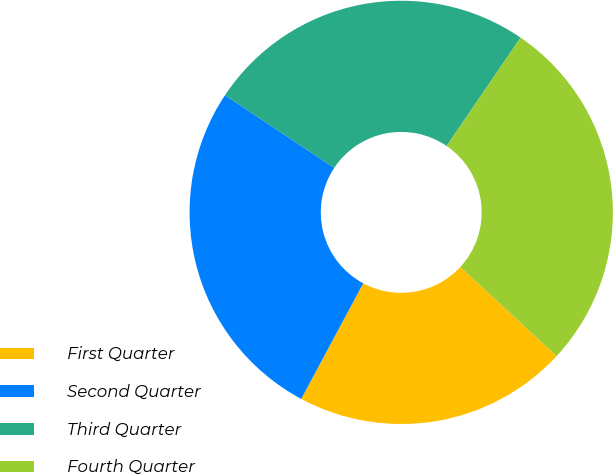Convert chart to OTSL. <chart><loc_0><loc_0><loc_500><loc_500><pie_chart><fcel>First Quarter<fcel>Second Quarter<fcel>Third Quarter<fcel>Fourth Quarter<nl><fcel>20.96%<fcel>26.51%<fcel>25.2%<fcel>27.34%<nl></chart> 